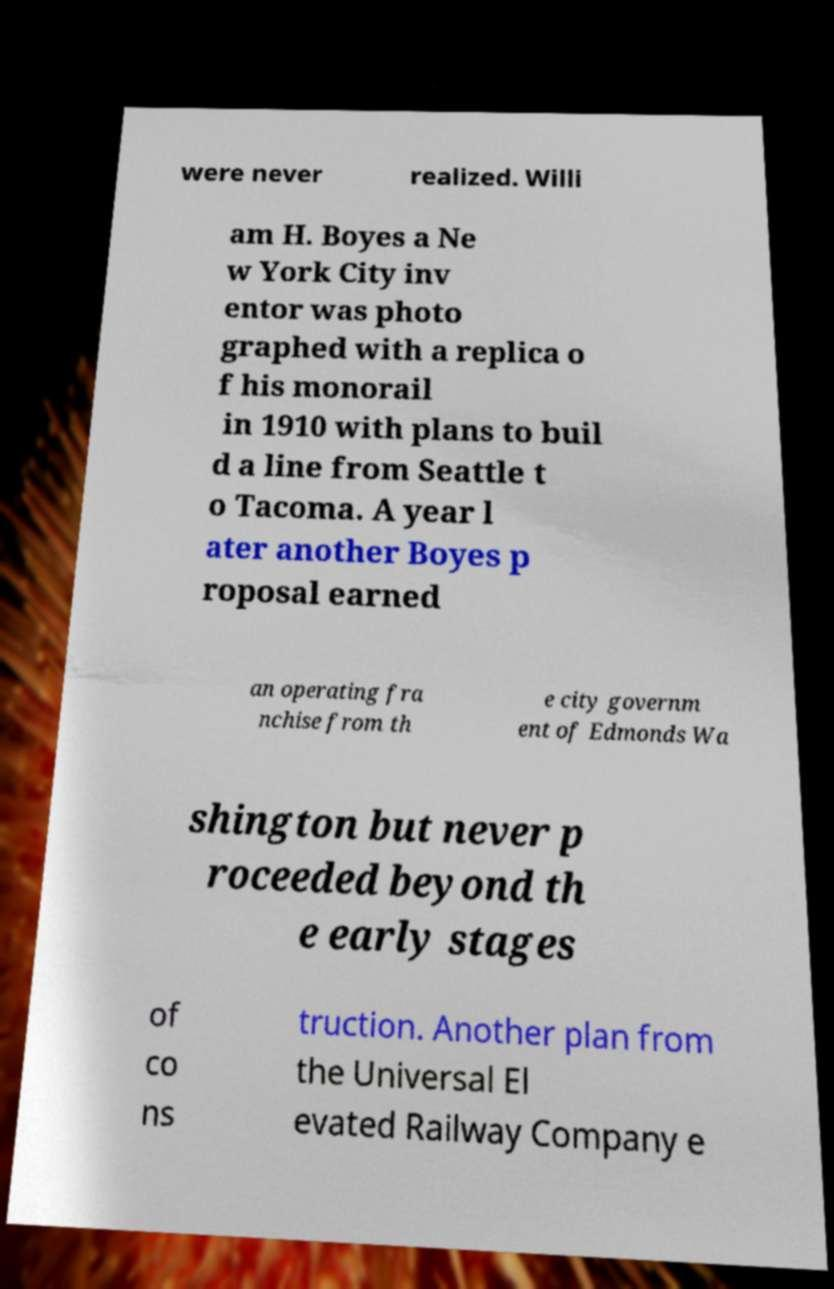Could you assist in decoding the text presented in this image and type it out clearly? were never realized. Willi am H. Boyes a Ne w York City inv entor was photo graphed with a replica o f his monorail in 1910 with plans to buil d a line from Seattle t o Tacoma. A year l ater another Boyes p roposal earned an operating fra nchise from th e city governm ent of Edmonds Wa shington but never p roceeded beyond th e early stages of co ns truction. Another plan from the Universal El evated Railway Company e 